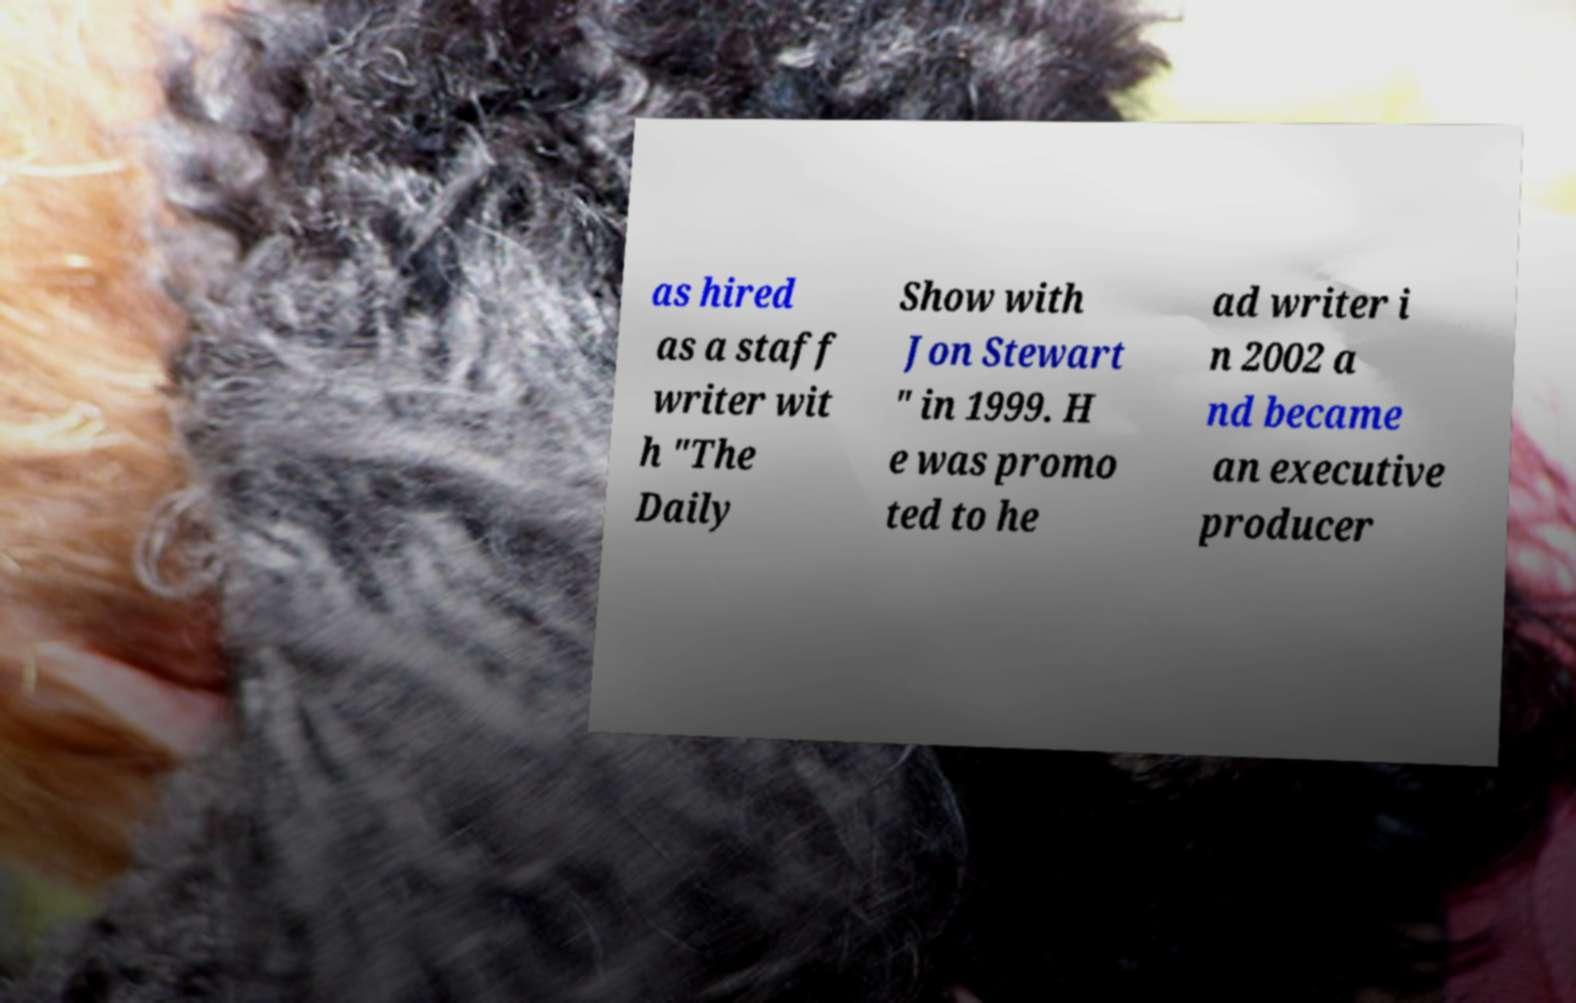Please read and relay the text visible in this image. What does it say? as hired as a staff writer wit h "The Daily Show with Jon Stewart " in 1999. H e was promo ted to he ad writer i n 2002 a nd became an executive producer 